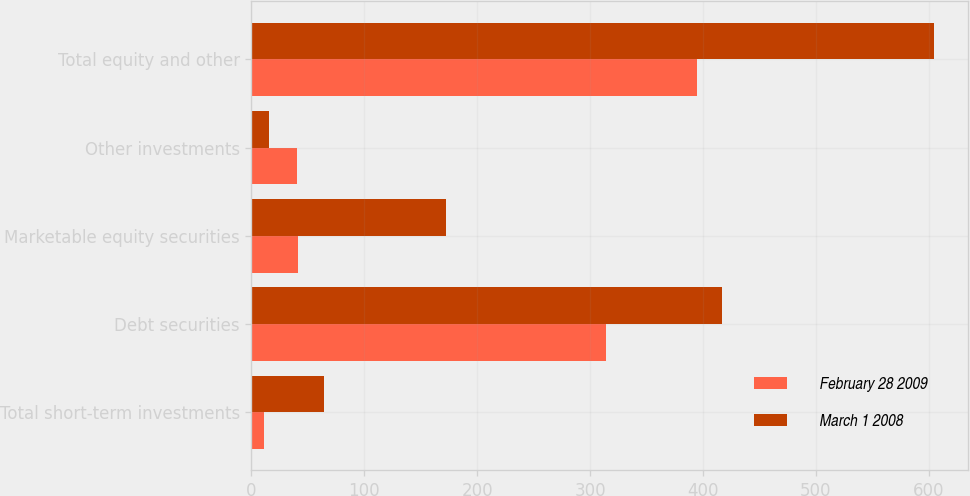Convert chart to OTSL. <chart><loc_0><loc_0><loc_500><loc_500><stacked_bar_chart><ecel><fcel>Total short-term investments<fcel>Debt securities<fcel>Marketable equity securities<fcel>Other investments<fcel>Total equity and other<nl><fcel>February 28 2009<fcel>11<fcel>314<fcel>41<fcel>40<fcel>395<nl><fcel>March 1 2008<fcel>64<fcel>417<fcel>172<fcel>16<fcel>605<nl></chart> 